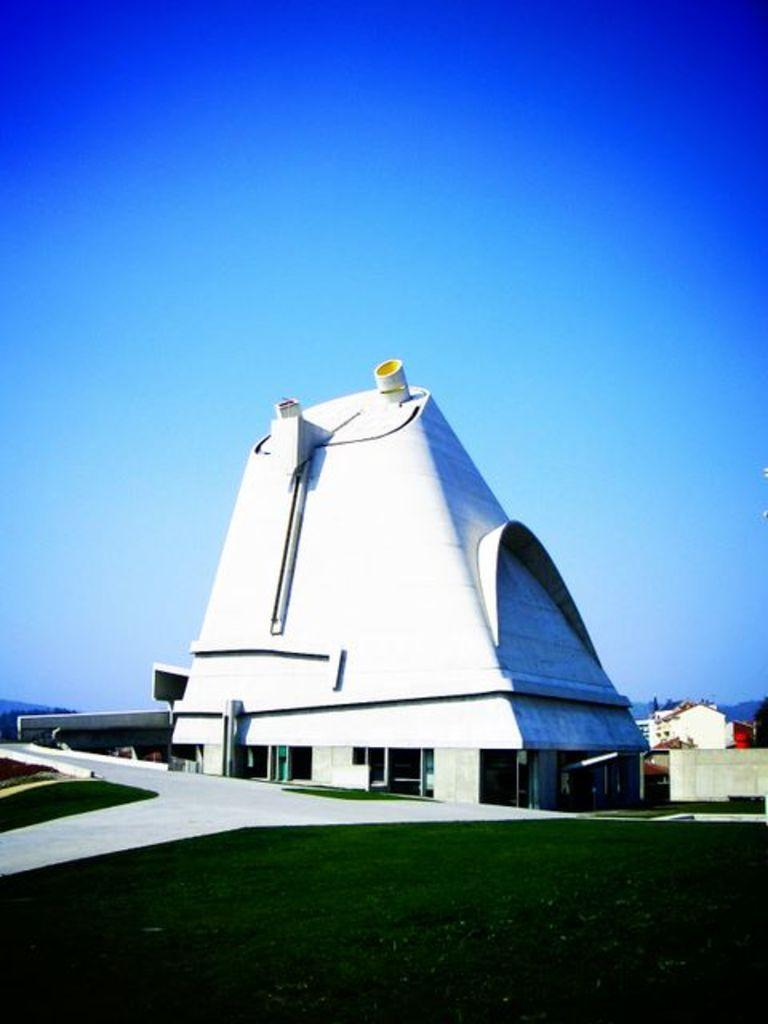What is the main structure in the center of the image? There is a building in the center of the image. What type of barrier can be seen in the image? There is a wall and a compound wall in the image. What type of vegetation is present in the image? There is grass in the image. What type of pathway is visible in the image? There is a road in the image. What can be seen in the background of the image? There is sky visible in the background of the image, and at least one building is present in the background. What type of bone is visible in the image? There is no bone present in the image. What is the weather like in the image? The provided facts do not mention the weather, so it cannot be determined from the image. 